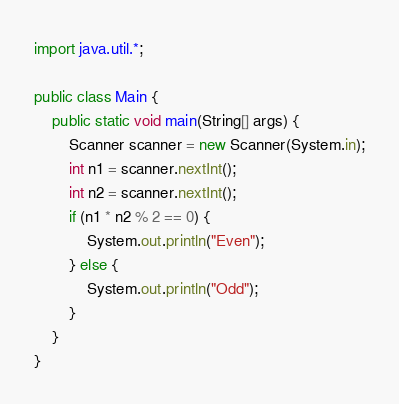<code> <loc_0><loc_0><loc_500><loc_500><_Java_>import java.util.*;
 
public class Main {
	public static void main(String[] args) {
    	Scanner scanner = new Scanner(System.in);
        int n1 = scanner.nextInt();
        int n2 = scanner.nextInt();
        if (n1 * n2 % 2 == 0) {
        	System.out.println("Even");
        } else {
        	System.out.println("Odd");
        }
    }
}</code> 